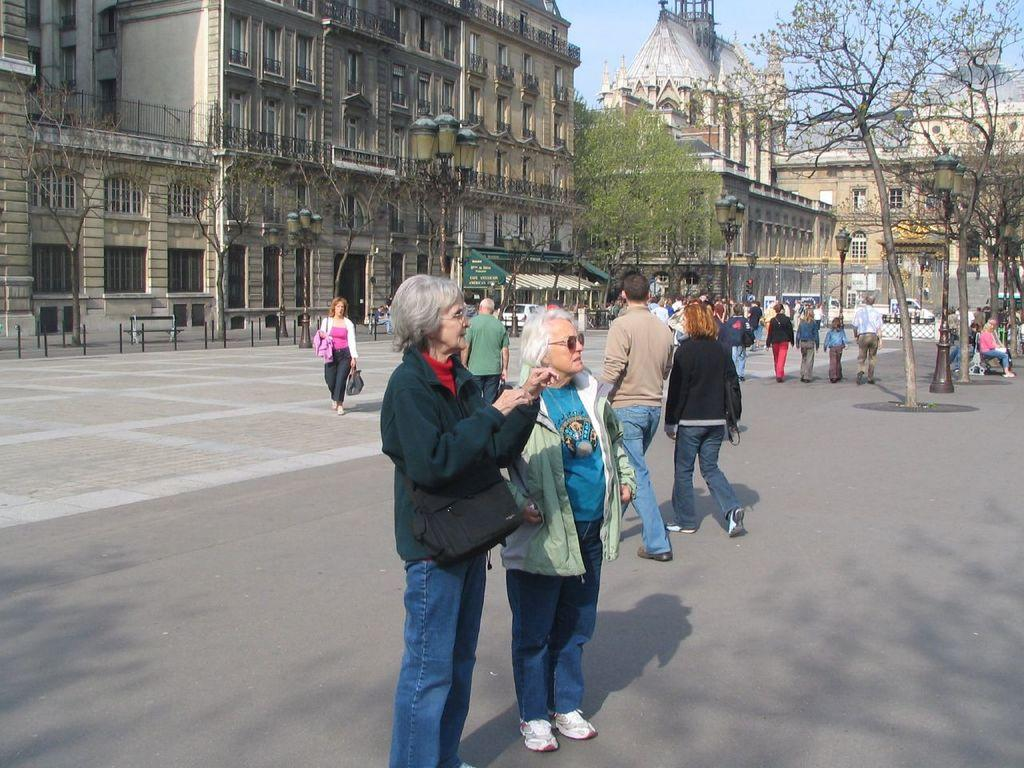Who or what can be seen in the image? There are people in the image. What type of structures are visible in the image? There are street lamps, buildings, and trees in the image. What part of the natural environment is visible in the image? The sky is visible in the image. What type of bucket is being used for treatment in the image? There is no bucket or treatment present in the image. 